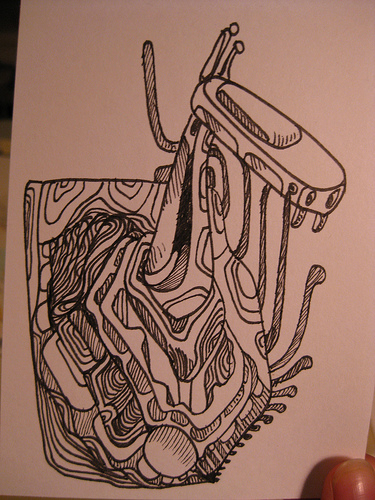<image>
Is the pen under the paper? No. The pen is not positioned under the paper. The vertical relationship between these objects is different. 